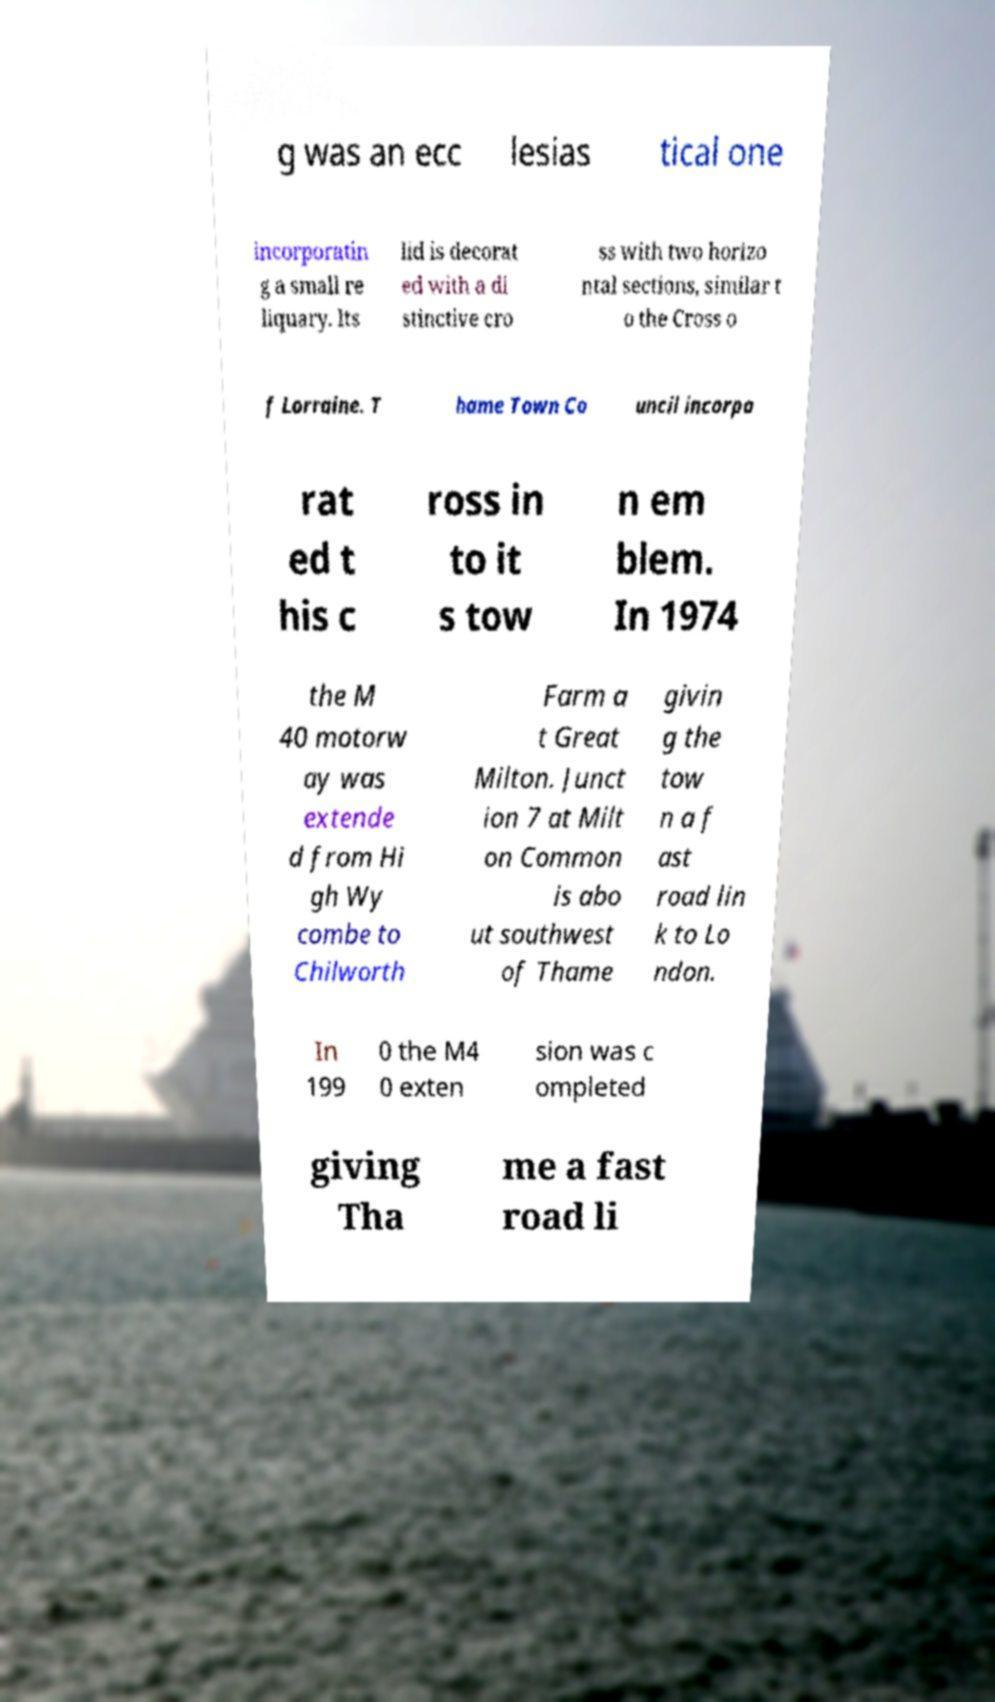Please read and relay the text visible in this image. What does it say? g was an ecc lesias tical one incorporatin g a small re liquary. Its lid is decorat ed with a di stinctive cro ss with two horizo ntal sections, similar t o the Cross o f Lorraine. T hame Town Co uncil incorpo rat ed t his c ross in to it s tow n em blem. In 1974 the M 40 motorw ay was extende d from Hi gh Wy combe to Chilworth Farm a t Great Milton. Junct ion 7 at Milt on Common is abo ut southwest of Thame givin g the tow n a f ast road lin k to Lo ndon. In 199 0 the M4 0 exten sion was c ompleted giving Tha me a fast road li 